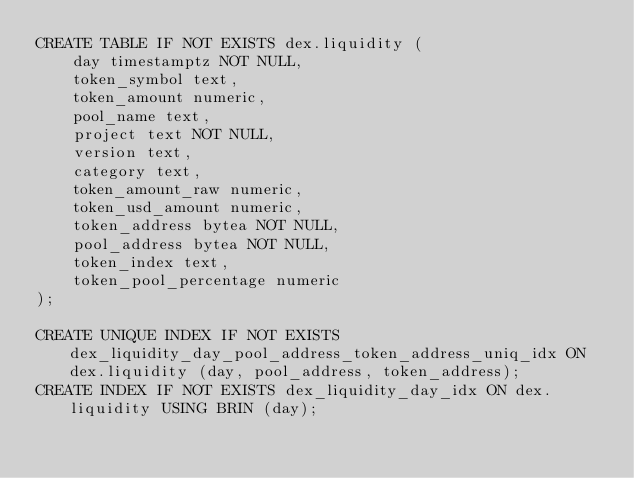Convert code to text. <code><loc_0><loc_0><loc_500><loc_500><_SQL_>CREATE TABLE IF NOT EXISTS dex.liquidity (
    day timestamptz NOT NULL,
    token_symbol text,
    token_amount numeric,
    pool_name text,
    project text NOT NULL,
    version text,
    category text,
    token_amount_raw numeric,
    token_usd_amount numeric,
    token_address bytea NOT NULL,
    pool_address bytea NOT NULL,
    token_index text,
    token_pool_percentage numeric
);

CREATE UNIQUE INDEX IF NOT EXISTS dex_liquidity_day_pool_address_token_address_uniq_idx ON dex.liquidity (day, pool_address, token_address);
CREATE INDEX IF NOT EXISTS dex_liquidity_day_idx ON dex.liquidity USING BRIN (day);</code> 